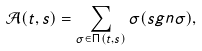<formula> <loc_0><loc_0><loc_500><loc_500>\mathcal { A } ( t , s ) = \sum _ { \sigma \in \Pi ( t , s ) } \sigma ( s g n \sigma ) ,</formula> 